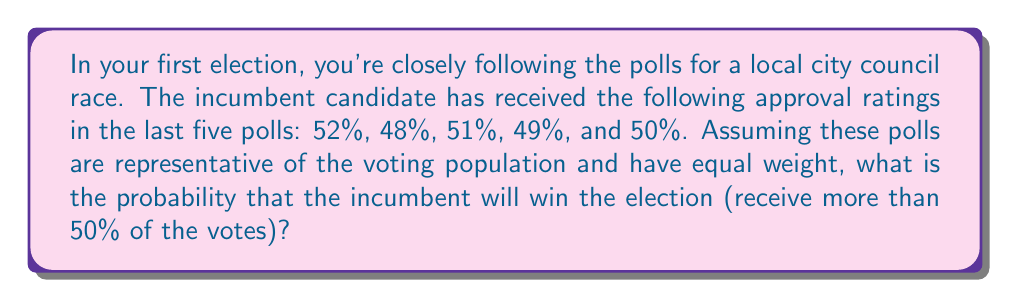Teach me how to tackle this problem. Let's approach this step-by-step:

1) First, we need to calculate the average approval rating from the polls:

   $$ \text{Average} = \frac{52\% + 48\% + 51\% + 49\% + 50\%}{5} = 50\% $$

2) Now, we need to calculate the standard deviation of the polls:

   $$ s = \sqrt{\frac{\sum(x_i - \bar{x})^2}{n-1}} $$

   where $x_i$ are the individual poll results, $\bar{x}$ is the mean, and $n$ is the number of polls.

3) Calculating the squared differences:

   $$(52 - 50)^2 = 4$$
   $$(48 - 50)^2 = 4$$
   $$(51 - 50)^2 = 1$$
   $$(49 - 50)^2 = 1$$
   $$(50 - 50)^2 = 0$$

4) Sum of squared differences: $4 + 4 + 1 + 1 + 0 = 10$

5) Standard deviation:

   $$ s = \sqrt{\frac{10}{5-1}} = \sqrt{2.5} \approx 1.58\% $$

6) To win, the incumbent needs more than 50% of the votes. We can use the normal distribution to calculate this probability.

7) The z-score for 50% is:

   $$ z = \frac{50 - 50}{1.58} = 0 $$

8) The probability of winning is the area to the right of z = 0 on the standard normal distribution, which is 0.5 or 50%.
Answer: $0.5$ or $50\%$ 